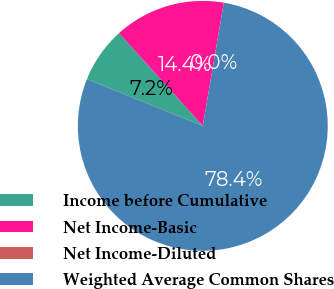<chart> <loc_0><loc_0><loc_500><loc_500><pie_chart><fcel>Income before Cumulative<fcel>Net Income-Basic<fcel>Net Income-Diluted<fcel>Weighted Average Common Shares<nl><fcel>7.2%<fcel>14.39%<fcel>0.0%<fcel>78.41%<nl></chart> 